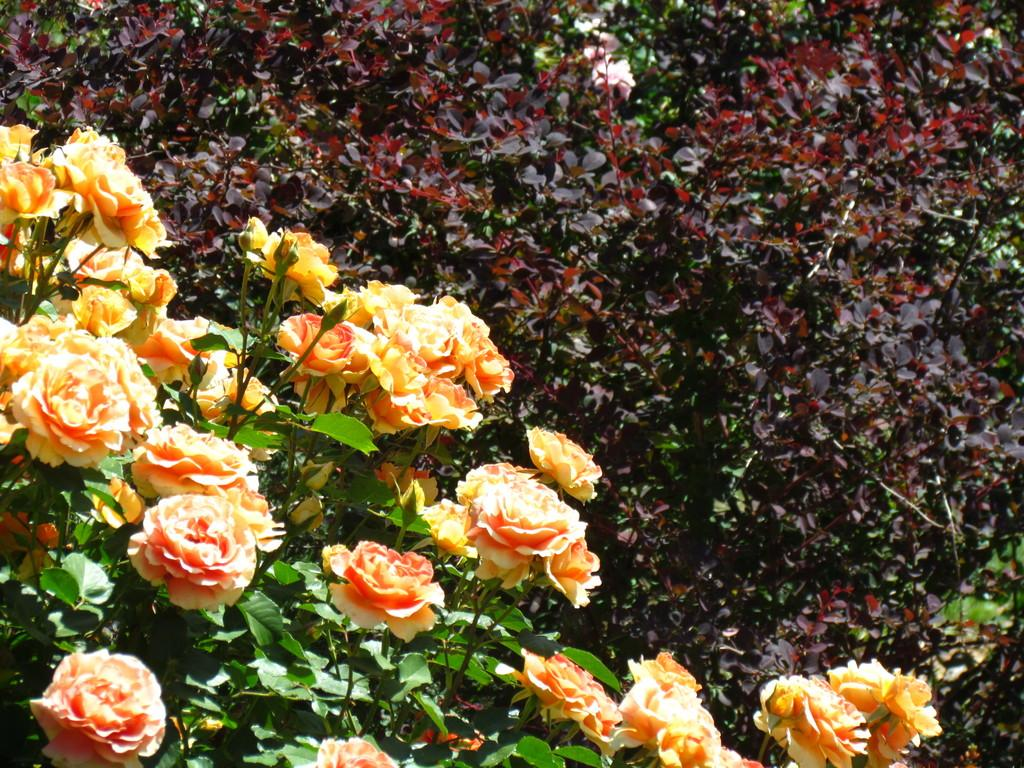What type of plants are in the foreground of the image? There are flower plants in the foreground of the image. What can be seen in the background of the image? There are plants in the background of the image. Where is the crate located in the image? There is no crate present in the image. What type of fan can be seen in the image? There is no fan present in the image. 